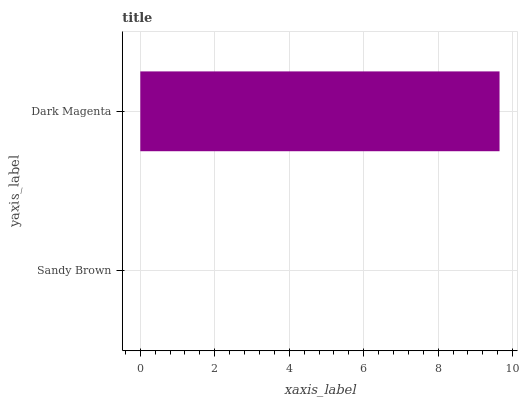Is Sandy Brown the minimum?
Answer yes or no. Yes. Is Dark Magenta the maximum?
Answer yes or no. Yes. Is Dark Magenta the minimum?
Answer yes or no. No. Is Dark Magenta greater than Sandy Brown?
Answer yes or no. Yes. Is Sandy Brown less than Dark Magenta?
Answer yes or no. Yes. Is Sandy Brown greater than Dark Magenta?
Answer yes or no. No. Is Dark Magenta less than Sandy Brown?
Answer yes or no. No. Is Dark Magenta the high median?
Answer yes or no. Yes. Is Sandy Brown the low median?
Answer yes or no. Yes. Is Sandy Brown the high median?
Answer yes or no. No. Is Dark Magenta the low median?
Answer yes or no. No. 